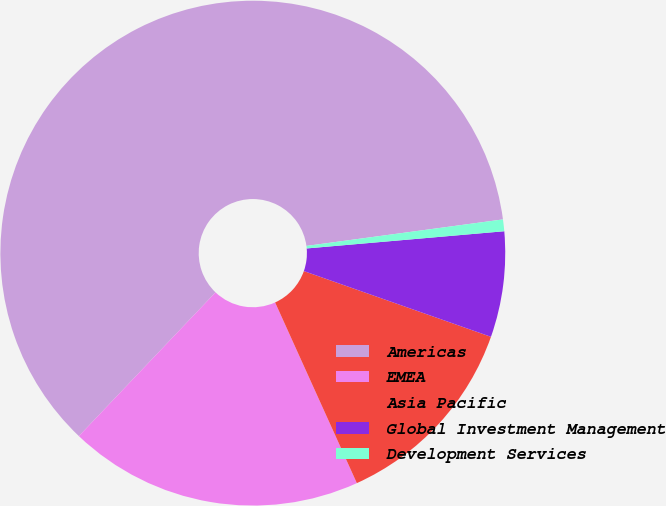<chart> <loc_0><loc_0><loc_500><loc_500><pie_chart><fcel>Americas<fcel>EMEA<fcel>Asia Pacific<fcel>Global Investment Management<fcel>Development Services<nl><fcel>60.76%<fcel>18.86%<fcel>12.86%<fcel>6.76%<fcel>0.75%<nl></chart> 